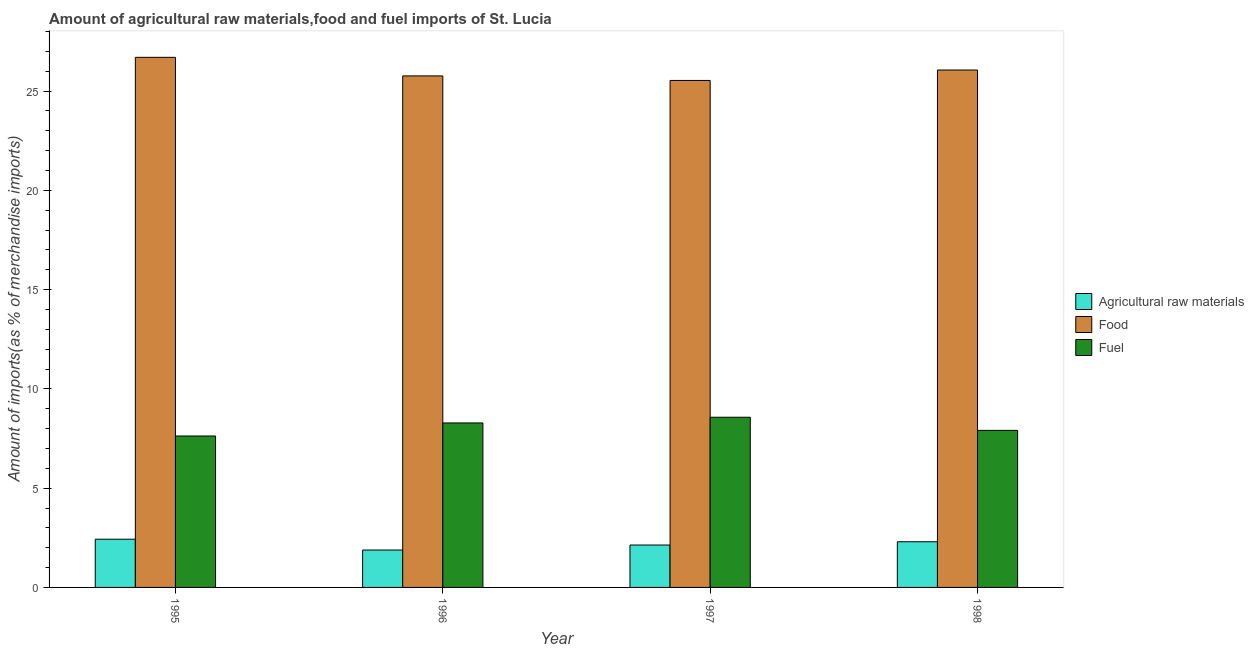In how many cases, is the number of bars for a given year not equal to the number of legend labels?
Offer a very short reply. 0. What is the percentage of fuel imports in 1996?
Offer a very short reply. 8.29. Across all years, what is the maximum percentage of fuel imports?
Provide a short and direct response. 8.57. Across all years, what is the minimum percentage of food imports?
Offer a very short reply. 25.54. In which year was the percentage of raw materials imports minimum?
Your answer should be compact. 1996. What is the total percentage of food imports in the graph?
Your response must be concise. 104.07. What is the difference between the percentage of fuel imports in 1995 and that in 1998?
Offer a terse response. -0.28. What is the difference between the percentage of fuel imports in 1997 and the percentage of food imports in 1995?
Offer a very short reply. 0.94. What is the average percentage of raw materials imports per year?
Provide a succinct answer. 2.19. In how many years, is the percentage of raw materials imports greater than 8 %?
Your answer should be very brief. 0. What is the ratio of the percentage of food imports in 1997 to that in 1998?
Your response must be concise. 0.98. Is the difference between the percentage of raw materials imports in 1995 and 1996 greater than the difference between the percentage of fuel imports in 1995 and 1996?
Give a very brief answer. No. What is the difference between the highest and the second highest percentage of raw materials imports?
Keep it short and to the point. 0.13. What is the difference between the highest and the lowest percentage of raw materials imports?
Provide a short and direct response. 0.55. Is the sum of the percentage of fuel imports in 1995 and 1998 greater than the maximum percentage of food imports across all years?
Give a very brief answer. Yes. What does the 2nd bar from the left in 1996 represents?
Offer a very short reply. Food. What does the 3rd bar from the right in 1996 represents?
Make the answer very short. Agricultural raw materials. Is it the case that in every year, the sum of the percentage of raw materials imports and percentage of food imports is greater than the percentage of fuel imports?
Your answer should be compact. Yes. How many bars are there?
Ensure brevity in your answer.  12. How many years are there in the graph?
Make the answer very short. 4. What is the difference between two consecutive major ticks on the Y-axis?
Offer a terse response. 5. Are the values on the major ticks of Y-axis written in scientific E-notation?
Your answer should be compact. No. How many legend labels are there?
Ensure brevity in your answer.  3. How are the legend labels stacked?
Provide a succinct answer. Vertical. What is the title of the graph?
Your response must be concise. Amount of agricultural raw materials,food and fuel imports of St. Lucia. What is the label or title of the X-axis?
Provide a short and direct response. Year. What is the label or title of the Y-axis?
Make the answer very short. Amount of imports(as % of merchandise imports). What is the Amount of imports(as % of merchandise imports) in Agricultural raw materials in 1995?
Ensure brevity in your answer.  2.43. What is the Amount of imports(as % of merchandise imports) of Food in 1995?
Your answer should be compact. 26.7. What is the Amount of imports(as % of merchandise imports) in Fuel in 1995?
Ensure brevity in your answer.  7.63. What is the Amount of imports(as % of merchandise imports) of Agricultural raw materials in 1996?
Offer a very short reply. 1.88. What is the Amount of imports(as % of merchandise imports) in Food in 1996?
Ensure brevity in your answer.  25.77. What is the Amount of imports(as % of merchandise imports) of Fuel in 1996?
Your answer should be compact. 8.29. What is the Amount of imports(as % of merchandise imports) of Agricultural raw materials in 1997?
Ensure brevity in your answer.  2.14. What is the Amount of imports(as % of merchandise imports) in Food in 1997?
Make the answer very short. 25.54. What is the Amount of imports(as % of merchandise imports) in Fuel in 1997?
Keep it short and to the point. 8.57. What is the Amount of imports(as % of merchandise imports) in Agricultural raw materials in 1998?
Ensure brevity in your answer.  2.3. What is the Amount of imports(as % of merchandise imports) of Food in 1998?
Provide a short and direct response. 26.06. What is the Amount of imports(as % of merchandise imports) of Fuel in 1998?
Your response must be concise. 7.91. Across all years, what is the maximum Amount of imports(as % of merchandise imports) of Agricultural raw materials?
Offer a terse response. 2.43. Across all years, what is the maximum Amount of imports(as % of merchandise imports) in Food?
Give a very brief answer. 26.7. Across all years, what is the maximum Amount of imports(as % of merchandise imports) in Fuel?
Ensure brevity in your answer.  8.57. Across all years, what is the minimum Amount of imports(as % of merchandise imports) of Agricultural raw materials?
Offer a terse response. 1.88. Across all years, what is the minimum Amount of imports(as % of merchandise imports) of Food?
Offer a terse response. 25.54. Across all years, what is the minimum Amount of imports(as % of merchandise imports) of Fuel?
Keep it short and to the point. 7.63. What is the total Amount of imports(as % of merchandise imports) in Agricultural raw materials in the graph?
Your response must be concise. 8.75. What is the total Amount of imports(as % of merchandise imports) in Food in the graph?
Ensure brevity in your answer.  104.07. What is the total Amount of imports(as % of merchandise imports) of Fuel in the graph?
Your response must be concise. 32.4. What is the difference between the Amount of imports(as % of merchandise imports) of Agricultural raw materials in 1995 and that in 1996?
Offer a terse response. 0.55. What is the difference between the Amount of imports(as % of merchandise imports) of Food in 1995 and that in 1996?
Offer a very short reply. 0.94. What is the difference between the Amount of imports(as % of merchandise imports) in Fuel in 1995 and that in 1996?
Keep it short and to the point. -0.66. What is the difference between the Amount of imports(as % of merchandise imports) of Agricultural raw materials in 1995 and that in 1997?
Your answer should be compact. 0.29. What is the difference between the Amount of imports(as % of merchandise imports) of Food in 1995 and that in 1997?
Provide a short and direct response. 1.16. What is the difference between the Amount of imports(as % of merchandise imports) in Fuel in 1995 and that in 1997?
Ensure brevity in your answer.  -0.94. What is the difference between the Amount of imports(as % of merchandise imports) of Agricultural raw materials in 1995 and that in 1998?
Offer a very short reply. 0.13. What is the difference between the Amount of imports(as % of merchandise imports) in Food in 1995 and that in 1998?
Offer a terse response. 0.64. What is the difference between the Amount of imports(as % of merchandise imports) of Fuel in 1995 and that in 1998?
Offer a terse response. -0.28. What is the difference between the Amount of imports(as % of merchandise imports) in Agricultural raw materials in 1996 and that in 1997?
Give a very brief answer. -0.25. What is the difference between the Amount of imports(as % of merchandise imports) of Food in 1996 and that in 1997?
Make the answer very short. 0.23. What is the difference between the Amount of imports(as % of merchandise imports) of Fuel in 1996 and that in 1997?
Your answer should be very brief. -0.29. What is the difference between the Amount of imports(as % of merchandise imports) in Agricultural raw materials in 1996 and that in 1998?
Offer a very short reply. -0.42. What is the difference between the Amount of imports(as % of merchandise imports) of Food in 1996 and that in 1998?
Your response must be concise. -0.3. What is the difference between the Amount of imports(as % of merchandise imports) of Fuel in 1996 and that in 1998?
Your response must be concise. 0.37. What is the difference between the Amount of imports(as % of merchandise imports) of Agricultural raw materials in 1997 and that in 1998?
Provide a short and direct response. -0.17. What is the difference between the Amount of imports(as % of merchandise imports) in Food in 1997 and that in 1998?
Ensure brevity in your answer.  -0.53. What is the difference between the Amount of imports(as % of merchandise imports) in Fuel in 1997 and that in 1998?
Keep it short and to the point. 0.66. What is the difference between the Amount of imports(as % of merchandise imports) of Agricultural raw materials in 1995 and the Amount of imports(as % of merchandise imports) of Food in 1996?
Provide a succinct answer. -23.34. What is the difference between the Amount of imports(as % of merchandise imports) in Agricultural raw materials in 1995 and the Amount of imports(as % of merchandise imports) in Fuel in 1996?
Offer a terse response. -5.86. What is the difference between the Amount of imports(as % of merchandise imports) of Food in 1995 and the Amount of imports(as % of merchandise imports) of Fuel in 1996?
Offer a terse response. 18.42. What is the difference between the Amount of imports(as % of merchandise imports) in Agricultural raw materials in 1995 and the Amount of imports(as % of merchandise imports) in Food in 1997?
Make the answer very short. -23.11. What is the difference between the Amount of imports(as % of merchandise imports) of Agricultural raw materials in 1995 and the Amount of imports(as % of merchandise imports) of Fuel in 1997?
Keep it short and to the point. -6.14. What is the difference between the Amount of imports(as % of merchandise imports) in Food in 1995 and the Amount of imports(as % of merchandise imports) in Fuel in 1997?
Keep it short and to the point. 18.13. What is the difference between the Amount of imports(as % of merchandise imports) in Agricultural raw materials in 1995 and the Amount of imports(as % of merchandise imports) in Food in 1998?
Provide a succinct answer. -23.64. What is the difference between the Amount of imports(as % of merchandise imports) of Agricultural raw materials in 1995 and the Amount of imports(as % of merchandise imports) of Fuel in 1998?
Provide a short and direct response. -5.48. What is the difference between the Amount of imports(as % of merchandise imports) of Food in 1995 and the Amount of imports(as % of merchandise imports) of Fuel in 1998?
Ensure brevity in your answer.  18.79. What is the difference between the Amount of imports(as % of merchandise imports) in Agricultural raw materials in 1996 and the Amount of imports(as % of merchandise imports) in Food in 1997?
Your response must be concise. -23.65. What is the difference between the Amount of imports(as % of merchandise imports) in Agricultural raw materials in 1996 and the Amount of imports(as % of merchandise imports) in Fuel in 1997?
Your answer should be very brief. -6.69. What is the difference between the Amount of imports(as % of merchandise imports) of Food in 1996 and the Amount of imports(as % of merchandise imports) of Fuel in 1997?
Your answer should be compact. 17.19. What is the difference between the Amount of imports(as % of merchandise imports) of Agricultural raw materials in 1996 and the Amount of imports(as % of merchandise imports) of Food in 1998?
Keep it short and to the point. -24.18. What is the difference between the Amount of imports(as % of merchandise imports) in Agricultural raw materials in 1996 and the Amount of imports(as % of merchandise imports) in Fuel in 1998?
Your answer should be very brief. -6.03. What is the difference between the Amount of imports(as % of merchandise imports) of Food in 1996 and the Amount of imports(as % of merchandise imports) of Fuel in 1998?
Provide a succinct answer. 17.86. What is the difference between the Amount of imports(as % of merchandise imports) of Agricultural raw materials in 1997 and the Amount of imports(as % of merchandise imports) of Food in 1998?
Your answer should be very brief. -23.93. What is the difference between the Amount of imports(as % of merchandise imports) of Agricultural raw materials in 1997 and the Amount of imports(as % of merchandise imports) of Fuel in 1998?
Your answer should be compact. -5.78. What is the difference between the Amount of imports(as % of merchandise imports) in Food in 1997 and the Amount of imports(as % of merchandise imports) in Fuel in 1998?
Your answer should be compact. 17.63. What is the average Amount of imports(as % of merchandise imports) in Agricultural raw materials per year?
Provide a succinct answer. 2.19. What is the average Amount of imports(as % of merchandise imports) of Food per year?
Your answer should be compact. 26.02. What is the average Amount of imports(as % of merchandise imports) in Fuel per year?
Provide a short and direct response. 8.1. In the year 1995, what is the difference between the Amount of imports(as % of merchandise imports) in Agricultural raw materials and Amount of imports(as % of merchandise imports) in Food?
Provide a succinct answer. -24.27. In the year 1995, what is the difference between the Amount of imports(as % of merchandise imports) of Agricultural raw materials and Amount of imports(as % of merchandise imports) of Fuel?
Your answer should be compact. -5.2. In the year 1995, what is the difference between the Amount of imports(as % of merchandise imports) in Food and Amount of imports(as % of merchandise imports) in Fuel?
Give a very brief answer. 19.07. In the year 1996, what is the difference between the Amount of imports(as % of merchandise imports) in Agricultural raw materials and Amount of imports(as % of merchandise imports) in Food?
Your answer should be very brief. -23.88. In the year 1996, what is the difference between the Amount of imports(as % of merchandise imports) of Agricultural raw materials and Amount of imports(as % of merchandise imports) of Fuel?
Your response must be concise. -6.4. In the year 1996, what is the difference between the Amount of imports(as % of merchandise imports) of Food and Amount of imports(as % of merchandise imports) of Fuel?
Offer a very short reply. 17.48. In the year 1997, what is the difference between the Amount of imports(as % of merchandise imports) in Agricultural raw materials and Amount of imports(as % of merchandise imports) in Food?
Keep it short and to the point. -23.4. In the year 1997, what is the difference between the Amount of imports(as % of merchandise imports) in Agricultural raw materials and Amount of imports(as % of merchandise imports) in Fuel?
Give a very brief answer. -6.44. In the year 1997, what is the difference between the Amount of imports(as % of merchandise imports) in Food and Amount of imports(as % of merchandise imports) in Fuel?
Provide a short and direct response. 16.97. In the year 1998, what is the difference between the Amount of imports(as % of merchandise imports) of Agricultural raw materials and Amount of imports(as % of merchandise imports) of Food?
Offer a terse response. -23.76. In the year 1998, what is the difference between the Amount of imports(as % of merchandise imports) of Agricultural raw materials and Amount of imports(as % of merchandise imports) of Fuel?
Give a very brief answer. -5.61. In the year 1998, what is the difference between the Amount of imports(as % of merchandise imports) of Food and Amount of imports(as % of merchandise imports) of Fuel?
Provide a short and direct response. 18.15. What is the ratio of the Amount of imports(as % of merchandise imports) in Agricultural raw materials in 1995 to that in 1996?
Offer a very short reply. 1.29. What is the ratio of the Amount of imports(as % of merchandise imports) of Food in 1995 to that in 1996?
Provide a short and direct response. 1.04. What is the ratio of the Amount of imports(as % of merchandise imports) in Fuel in 1995 to that in 1996?
Your answer should be very brief. 0.92. What is the ratio of the Amount of imports(as % of merchandise imports) in Agricultural raw materials in 1995 to that in 1997?
Make the answer very short. 1.14. What is the ratio of the Amount of imports(as % of merchandise imports) of Food in 1995 to that in 1997?
Make the answer very short. 1.05. What is the ratio of the Amount of imports(as % of merchandise imports) of Fuel in 1995 to that in 1997?
Give a very brief answer. 0.89. What is the ratio of the Amount of imports(as % of merchandise imports) in Agricultural raw materials in 1995 to that in 1998?
Your answer should be very brief. 1.06. What is the ratio of the Amount of imports(as % of merchandise imports) of Food in 1995 to that in 1998?
Provide a short and direct response. 1.02. What is the ratio of the Amount of imports(as % of merchandise imports) in Agricultural raw materials in 1996 to that in 1997?
Give a very brief answer. 0.88. What is the ratio of the Amount of imports(as % of merchandise imports) of Fuel in 1996 to that in 1997?
Your response must be concise. 0.97. What is the ratio of the Amount of imports(as % of merchandise imports) in Agricultural raw materials in 1996 to that in 1998?
Offer a very short reply. 0.82. What is the ratio of the Amount of imports(as % of merchandise imports) of Food in 1996 to that in 1998?
Offer a very short reply. 0.99. What is the ratio of the Amount of imports(as % of merchandise imports) in Fuel in 1996 to that in 1998?
Provide a succinct answer. 1.05. What is the ratio of the Amount of imports(as % of merchandise imports) in Agricultural raw materials in 1997 to that in 1998?
Offer a terse response. 0.93. What is the ratio of the Amount of imports(as % of merchandise imports) of Food in 1997 to that in 1998?
Provide a succinct answer. 0.98. What is the ratio of the Amount of imports(as % of merchandise imports) of Fuel in 1997 to that in 1998?
Your answer should be compact. 1.08. What is the difference between the highest and the second highest Amount of imports(as % of merchandise imports) in Agricultural raw materials?
Offer a terse response. 0.13. What is the difference between the highest and the second highest Amount of imports(as % of merchandise imports) of Food?
Provide a succinct answer. 0.64. What is the difference between the highest and the second highest Amount of imports(as % of merchandise imports) in Fuel?
Provide a short and direct response. 0.29. What is the difference between the highest and the lowest Amount of imports(as % of merchandise imports) in Agricultural raw materials?
Keep it short and to the point. 0.55. What is the difference between the highest and the lowest Amount of imports(as % of merchandise imports) of Food?
Make the answer very short. 1.16. What is the difference between the highest and the lowest Amount of imports(as % of merchandise imports) of Fuel?
Offer a terse response. 0.94. 